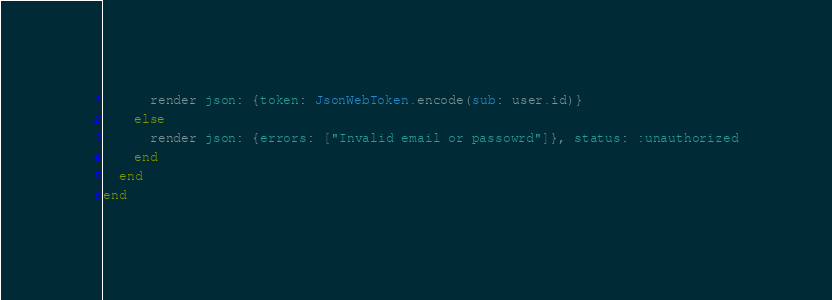Convert code to text. <code><loc_0><loc_0><loc_500><loc_500><_Ruby_>      render json: {token: JsonWebToken.encode(sub: user.id)}
    else
      render json: {errors: ["Invalid email or passowrd"]}, status: :unauthorized
    end
  end
end
</code> 